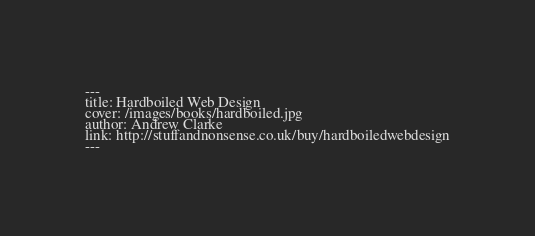Convert code to text. <code><loc_0><loc_0><loc_500><loc_500><_HTML_>---
title: Hardboiled Web Design
cover: /images/books/hardboiled.jpg
author: Andrew Clarke
link: http://stuffandnonsense.co.uk/buy/hardboiledwebdesign
---
</code> 